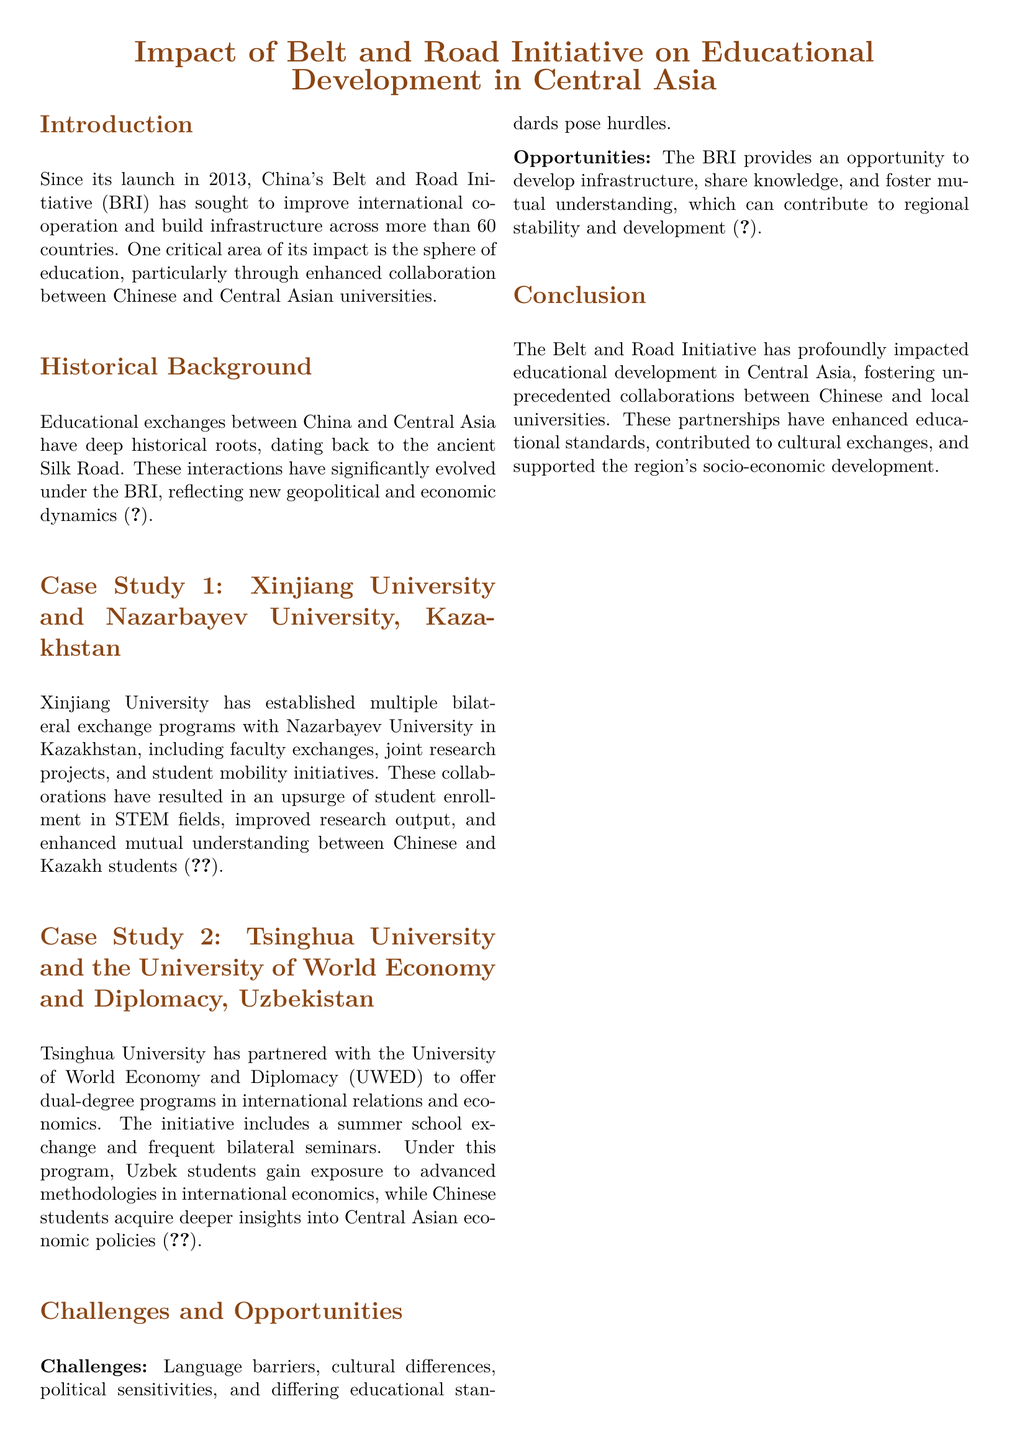What is the focus of the Belt and Road Initiative? The main focus of the Belt and Road Initiative is to improve international cooperation and build infrastructure across more than 60 countries.
Answer: international cooperation and infrastructure When was the Belt and Road Initiative launched? The document states that the Belt and Road Initiative was launched in 2013.
Answer: 2013 Which two universities are involved in Case Study 1? Case Study 1 mentions the collaboration between Xinjiang University and Nazarbayev University.
Answer: Xinjiang University and Nazarbayev University What type of degree programs does Tsinghua University offer with UWED? Tsinghua University offers dual-degree programs in international relations and economics with UWED.
Answer: dual-degree programs in international relations and economics What is one challenge highlighted in the document? The document lists language barriers, cultural differences, political sensitivities, and differing educational standards as challenges.
Answer: language barriers What is a key opportunity provided by the BRI? The BRI provides an opportunity to develop infrastructure, share knowledge, and foster mutual understanding.
Answer: develop infrastructure How have collaborations impacted student enrollment in STEM fields? Collaborations between Xinjiang University and Nazarbayev University have resulted in an upsurge of student enrollment in STEM fields.
Answer: upsurge of student enrollment in STEM fields In which country is UWED located? UWED, or the University of World Economy and Diplomacy, is located in Uzbekistan.
Answer: Uzbekistan 